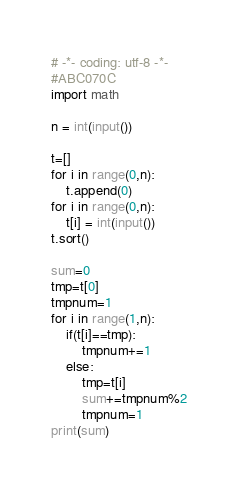<code> <loc_0><loc_0><loc_500><loc_500><_Python_># -*- coding: utf-8 -*-
#ABC070C
import math

n = int(input())

t=[]
for i in range(0,n):
	t.append(0)
for i in range(0,n):
    t[i] = int(input())
t.sort()

sum=0
tmp=t[0]
tmpnum=1
for i in range(1,n):
	if(t[i]==tmp):
		tmpnum+=1
	else:
		tmp=t[i]
		sum+=tmpnum%2
		tmpnum=1
print(sum)</code> 